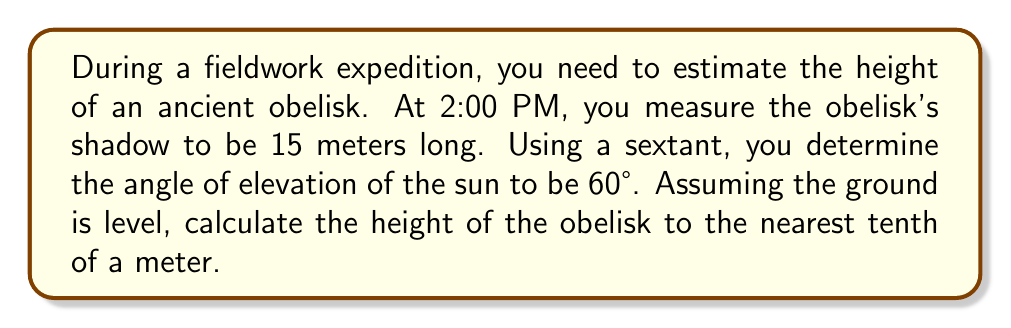Give your solution to this math problem. Let's approach this step-by-step using trigonometry:

1) We can model this situation as a right triangle, where:
   - The obelisk forms the vertical side (opposite to the sun's angle)
   - The shadow forms the horizontal side (adjacent to the sun's angle)
   - The sun's rays form the hypotenuse

2) We know:
   - The length of the shadow (adjacent) = 15 meters
   - The angle of elevation of the sun = 60°

3) We need to find the height of the obelisk, which is the opposite side in our right triangle.

4) The trigonometric ratio that relates the opposite side to the adjacent side is the tangent:

   $$\tan \theta = \frac{\text{opposite}}{\text{adjacent}}$$

5) Substituting our known values:

   $$\tan 60° = \frac{\text{height}}{15}$$

6) We can solve this for height:

   $$\text{height} = 15 \tan 60°$$

7) We know that $\tan 60° = \sqrt{3}$, so:

   $$\text{height} = 15\sqrt{3}$$

8) Calculate this:
   $$15\sqrt{3} \approx 25.98$$

9) Rounding to the nearest tenth:

   Height ≈ 26.0 meters

This method demonstrates how trigonometric principles can be applied in practical fieldwork situations to estimate the heights of tall structures.
Answer: 26.0 meters 